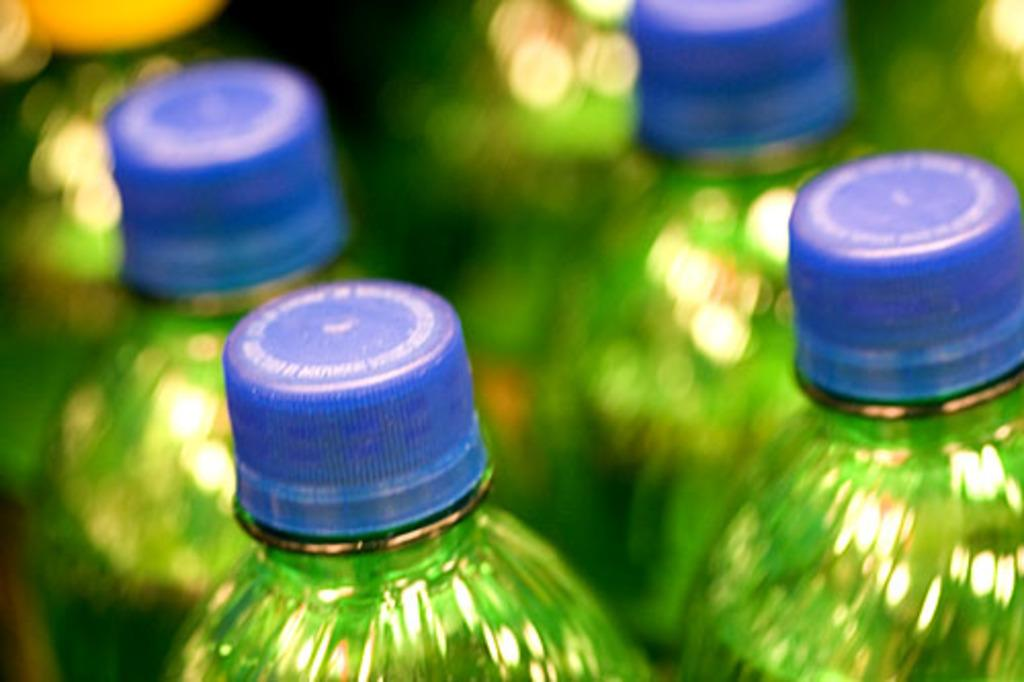What type of bottles are present in the image? There are many green bottles in the image. What color are the caps on the bottles? The bottles have blue caps. What type of paper is being used to make the rice in the image? There is no paper or rice present in the image; it only features green bottles with blue caps. 